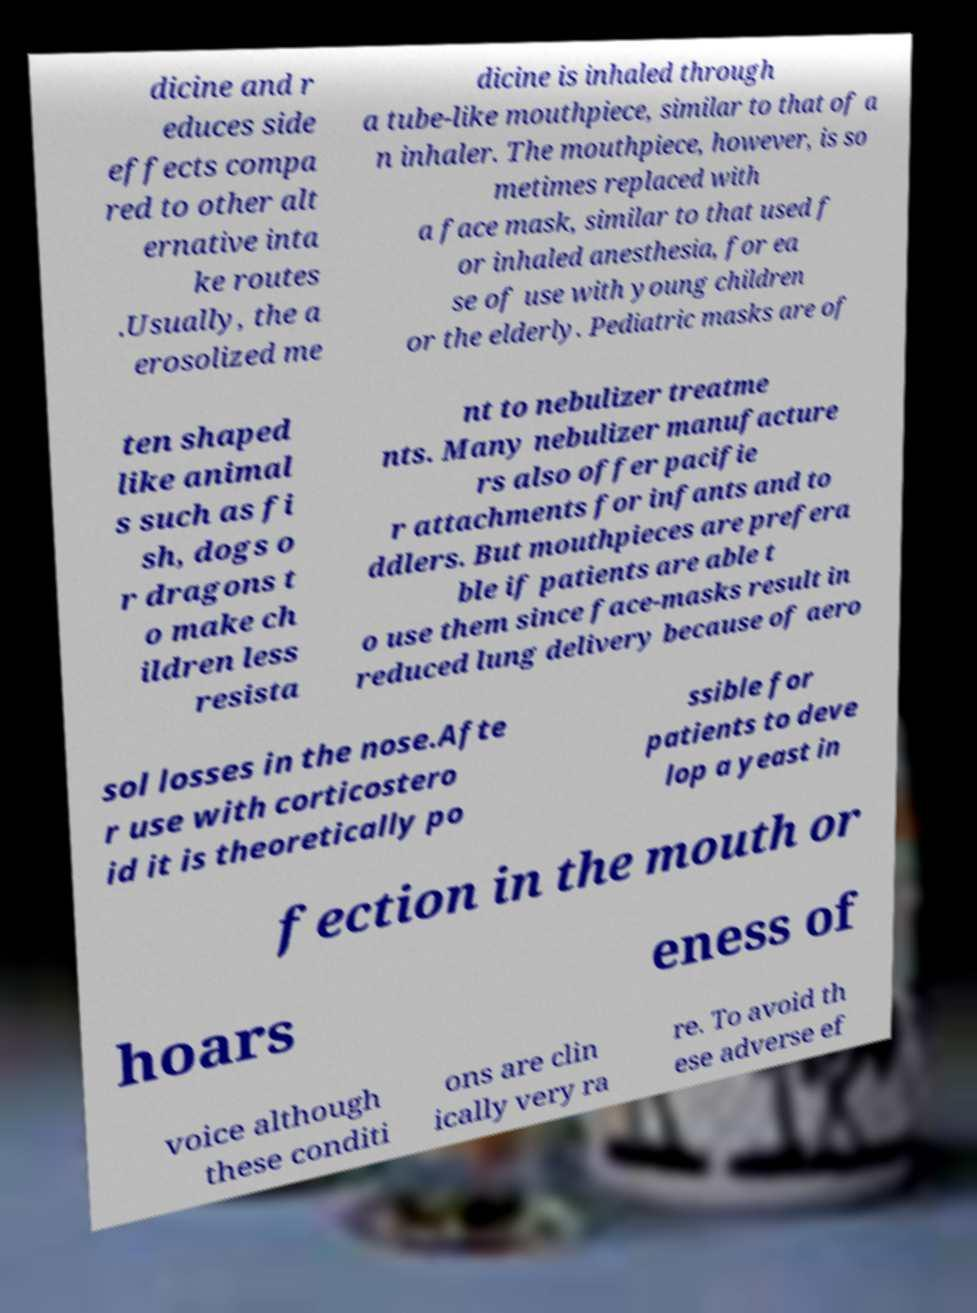Can you read and provide the text displayed in the image?This photo seems to have some interesting text. Can you extract and type it out for me? dicine and r educes side effects compa red to other alt ernative inta ke routes .Usually, the a erosolized me dicine is inhaled through a tube-like mouthpiece, similar to that of a n inhaler. The mouthpiece, however, is so metimes replaced with a face mask, similar to that used f or inhaled anesthesia, for ea se of use with young children or the elderly. Pediatric masks are of ten shaped like animal s such as fi sh, dogs o r dragons t o make ch ildren less resista nt to nebulizer treatme nts. Many nebulizer manufacture rs also offer pacifie r attachments for infants and to ddlers. But mouthpieces are prefera ble if patients are able t o use them since face-masks result in reduced lung delivery because of aero sol losses in the nose.Afte r use with corticostero id it is theoretically po ssible for patients to deve lop a yeast in fection in the mouth or hoars eness of voice although these conditi ons are clin ically very ra re. To avoid th ese adverse ef 